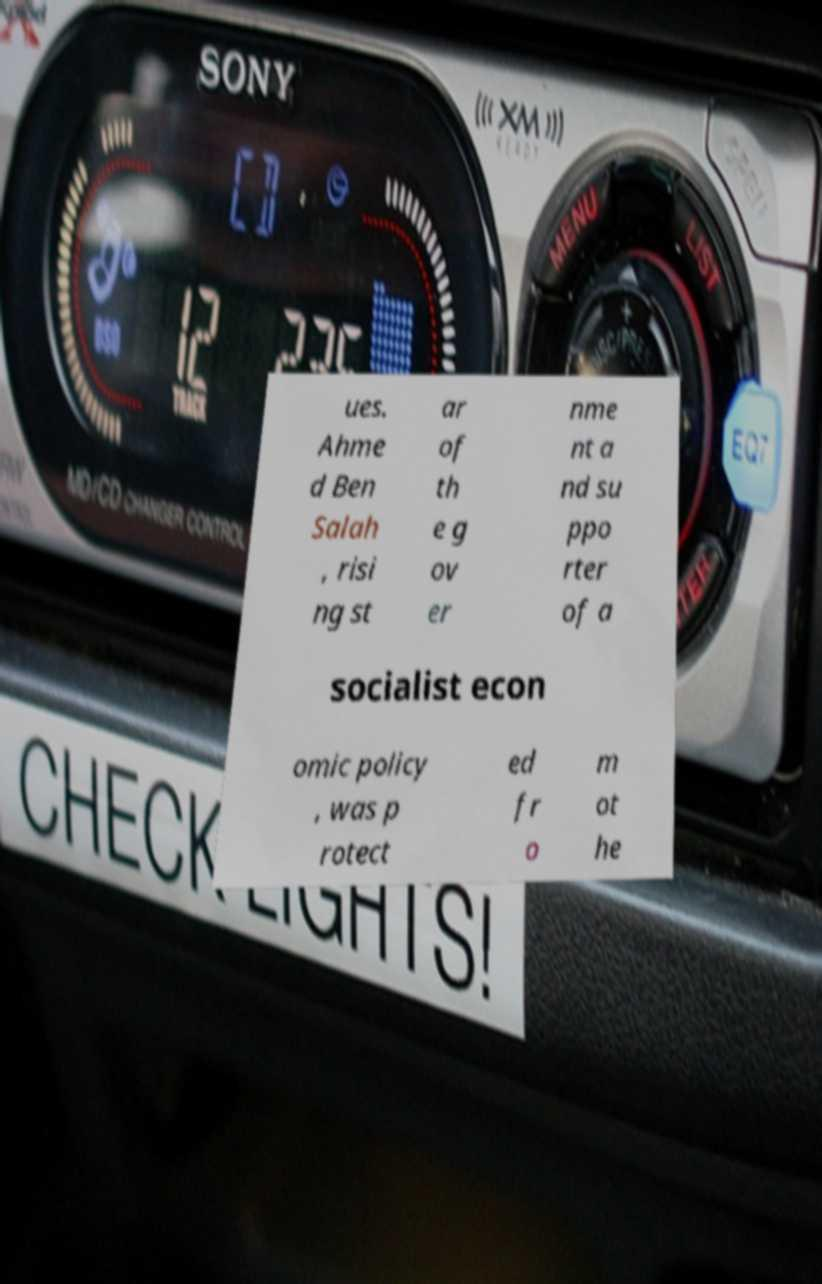Please read and relay the text visible in this image. What does it say? ues. Ahme d Ben Salah , risi ng st ar of th e g ov er nme nt a nd su ppo rter of a socialist econ omic policy , was p rotect ed fr o m ot he 